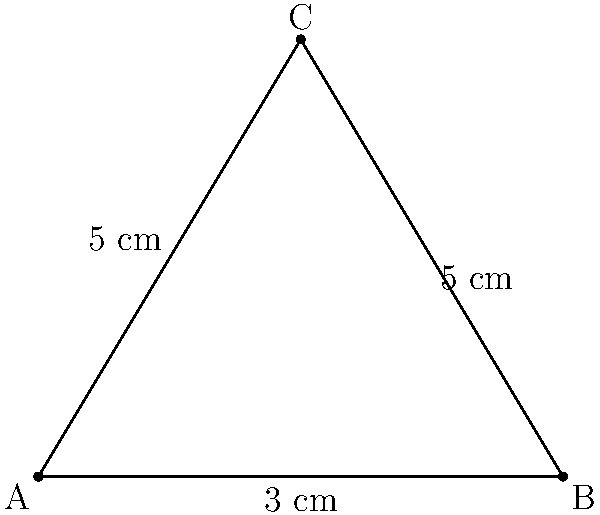A patient presents with triangular-shaped alopecia on their scalp. The affected area can be approximated by a triangle with sides measuring 3 cm, 5 cm, and 5 cm. Calculate the surface area of the scalp affected by alopecia. To calculate the surface area of the triangular-shaped alopecia, we can use Heron's formula:

1. First, calculate the semi-perimeter (s):
   $s = \frac{a + b + c}{2}$, where a, b, and c are the side lengths
   $s = \frac{3 + 5 + 5}{2} = \frac{13}{2} = 6.5$ cm

2. Apply Heron's formula:
   $A = \sqrt{s(s-a)(s-b)(s-c)}$

   Where:
   $A$ is the area
   $s$ is the semi-perimeter
   $a$, $b$, and $c$ are the side lengths

3. Substitute the values:
   $A = \sqrt{6.5(6.5-3)(6.5-5)(6.5-5)}$
   $A = \sqrt{6.5 \times 3.5 \times 1.5 \times 1.5}$

4. Calculate:
   $A = \sqrt{51.1875} \approx 7.15$ cm²

Therefore, the surface area of the scalp affected by alopecia is approximately 7.15 cm².
Answer: 7.15 cm² 